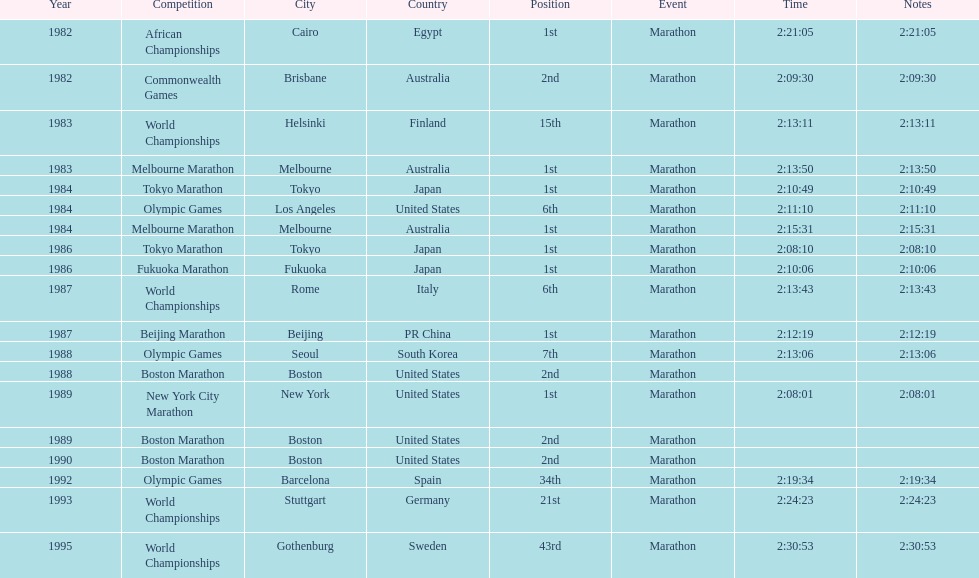Parse the full table. {'header': ['Year', 'Competition', 'City', 'Country', 'Position', 'Event', 'Time', 'Notes'], 'rows': [['1982', 'African Championships', 'Cairo', 'Egypt', '1st', 'Marathon', '2:21:05', '2:21:05'], ['1982', 'Commonwealth Games', 'Brisbane', 'Australia', '2nd', 'Marathon', '2:09:30', '2:09:30'], ['1983', 'World Championships', 'Helsinki', 'Finland', '15th', 'Marathon', '2:13:11', '2:13:11'], ['1983', 'Melbourne Marathon', 'Melbourne', 'Australia', '1st', 'Marathon', '2:13:50', '2:13:50'], ['1984', 'Tokyo Marathon', 'Tokyo', 'Japan', '1st', 'Marathon', '2:10:49', '2:10:49'], ['1984', 'Olympic Games', 'Los Angeles', 'United States', '6th', 'Marathon', '2:11:10', '2:11:10'], ['1984', 'Melbourne Marathon', 'Melbourne', 'Australia', '1st', 'Marathon', '2:15:31', '2:15:31'], ['1986', 'Tokyo Marathon', 'Tokyo', 'Japan', '1st', 'Marathon', '2:08:10', '2:08:10'], ['1986', 'Fukuoka Marathon', 'Fukuoka', 'Japan', '1st', 'Marathon', '2:10:06', '2:10:06'], ['1987', 'World Championships', 'Rome', 'Italy', '6th', 'Marathon', '2:13:43', '2:13:43'], ['1987', 'Beijing Marathon', 'Beijing', 'PR China', '1st', 'Marathon', '2:12:19', '2:12:19'], ['1988', 'Olympic Games', 'Seoul', 'South Korea', '7th', 'Marathon', '2:13:06', '2:13:06'], ['1988', 'Boston Marathon', 'Boston', 'United States', '2nd', 'Marathon', '', ''], ['1989', 'New York City Marathon', 'New York', 'United States', '1st', 'Marathon', '2:08:01', '2:08:01'], ['1989', 'Boston Marathon', 'Boston', 'United States', '2nd', 'Marathon', '', ''], ['1990', 'Boston Marathon', 'Boston', 'United States', '2nd', 'Marathon', '', ''], ['1992', 'Olympic Games', 'Barcelona', 'Spain', '34th', 'Marathon', '2:19:34', '2:19:34'], ['1993', 'World Championships', 'Stuttgart', 'Germany', '21st', 'Marathon', '2:24:23', '2:24:23'], ['1995', 'World Championships', 'Gothenburg', 'Sweden', '43rd', 'Marathon', '2:30:53', '2:30:53']]} What was the first marathon juma ikangaa won? 1982 African Championships. 